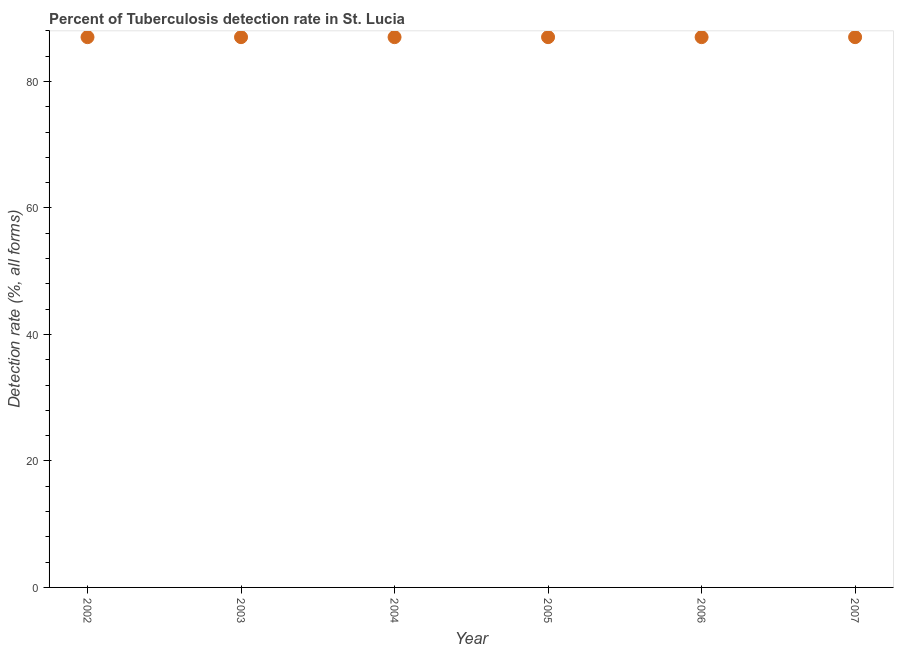What is the detection rate of tuberculosis in 2007?
Give a very brief answer. 87. Across all years, what is the maximum detection rate of tuberculosis?
Your answer should be very brief. 87. Across all years, what is the minimum detection rate of tuberculosis?
Provide a succinct answer. 87. In which year was the detection rate of tuberculosis maximum?
Give a very brief answer. 2002. What is the sum of the detection rate of tuberculosis?
Provide a succinct answer. 522. What is the average detection rate of tuberculosis per year?
Provide a short and direct response. 87. In how many years, is the detection rate of tuberculosis greater than 80 %?
Ensure brevity in your answer.  6. Do a majority of the years between 2005 and 2006 (inclusive) have detection rate of tuberculosis greater than 76 %?
Your answer should be compact. Yes. Is the detection rate of tuberculosis in 2002 less than that in 2006?
Your answer should be compact. No. Is the difference between the detection rate of tuberculosis in 2003 and 2005 greater than the difference between any two years?
Provide a short and direct response. Yes. What is the difference between the highest and the second highest detection rate of tuberculosis?
Your response must be concise. 0. Is the sum of the detection rate of tuberculosis in 2003 and 2007 greater than the maximum detection rate of tuberculosis across all years?
Give a very brief answer. Yes. What is the difference between the highest and the lowest detection rate of tuberculosis?
Keep it short and to the point. 0. How many years are there in the graph?
Give a very brief answer. 6. Are the values on the major ticks of Y-axis written in scientific E-notation?
Make the answer very short. No. Does the graph contain any zero values?
Offer a very short reply. No. Does the graph contain grids?
Your answer should be very brief. No. What is the title of the graph?
Your answer should be compact. Percent of Tuberculosis detection rate in St. Lucia. What is the label or title of the Y-axis?
Offer a terse response. Detection rate (%, all forms). What is the Detection rate (%, all forms) in 2003?
Give a very brief answer. 87. What is the Detection rate (%, all forms) in 2004?
Offer a very short reply. 87. What is the Detection rate (%, all forms) in 2006?
Provide a succinct answer. 87. What is the difference between the Detection rate (%, all forms) in 2002 and 2005?
Provide a short and direct response. 0. What is the difference between the Detection rate (%, all forms) in 2002 and 2006?
Offer a very short reply. 0. What is the difference between the Detection rate (%, all forms) in 2002 and 2007?
Keep it short and to the point. 0. What is the difference between the Detection rate (%, all forms) in 2003 and 2005?
Your answer should be very brief. 0. What is the difference between the Detection rate (%, all forms) in 2003 and 2006?
Make the answer very short. 0. What is the difference between the Detection rate (%, all forms) in 2003 and 2007?
Your answer should be very brief. 0. What is the difference between the Detection rate (%, all forms) in 2004 and 2006?
Make the answer very short. 0. What is the difference between the Detection rate (%, all forms) in 2004 and 2007?
Your response must be concise. 0. What is the difference between the Detection rate (%, all forms) in 2005 and 2007?
Your answer should be compact. 0. What is the difference between the Detection rate (%, all forms) in 2006 and 2007?
Give a very brief answer. 0. What is the ratio of the Detection rate (%, all forms) in 2002 to that in 2003?
Your response must be concise. 1. What is the ratio of the Detection rate (%, all forms) in 2002 to that in 2005?
Give a very brief answer. 1. What is the ratio of the Detection rate (%, all forms) in 2002 to that in 2007?
Your response must be concise. 1. What is the ratio of the Detection rate (%, all forms) in 2003 to that in 2005?
Give a very brief answer. 1. What is the ratio of the Detection rate (%, all forms) in 2003 to that in 2006?
Keep it short and to the point. 1. What is the ratio of the Detection rate (%, all forms) in 2003 to that in 2007?
Your answer should be compact. 1. What is the ratio of the Detection rate (%, all forms) in 2004 to that in 2005?
Keep it short and to the point. 1. What is the ratio of the Detection rate (%, all forms) in 2004 to that in 2006?
Keep it short and to the point. 1. What is the ratio of the Detection rate (%, all forms) in 2005 to that in 2007?
Give a very brief answer. 1. 